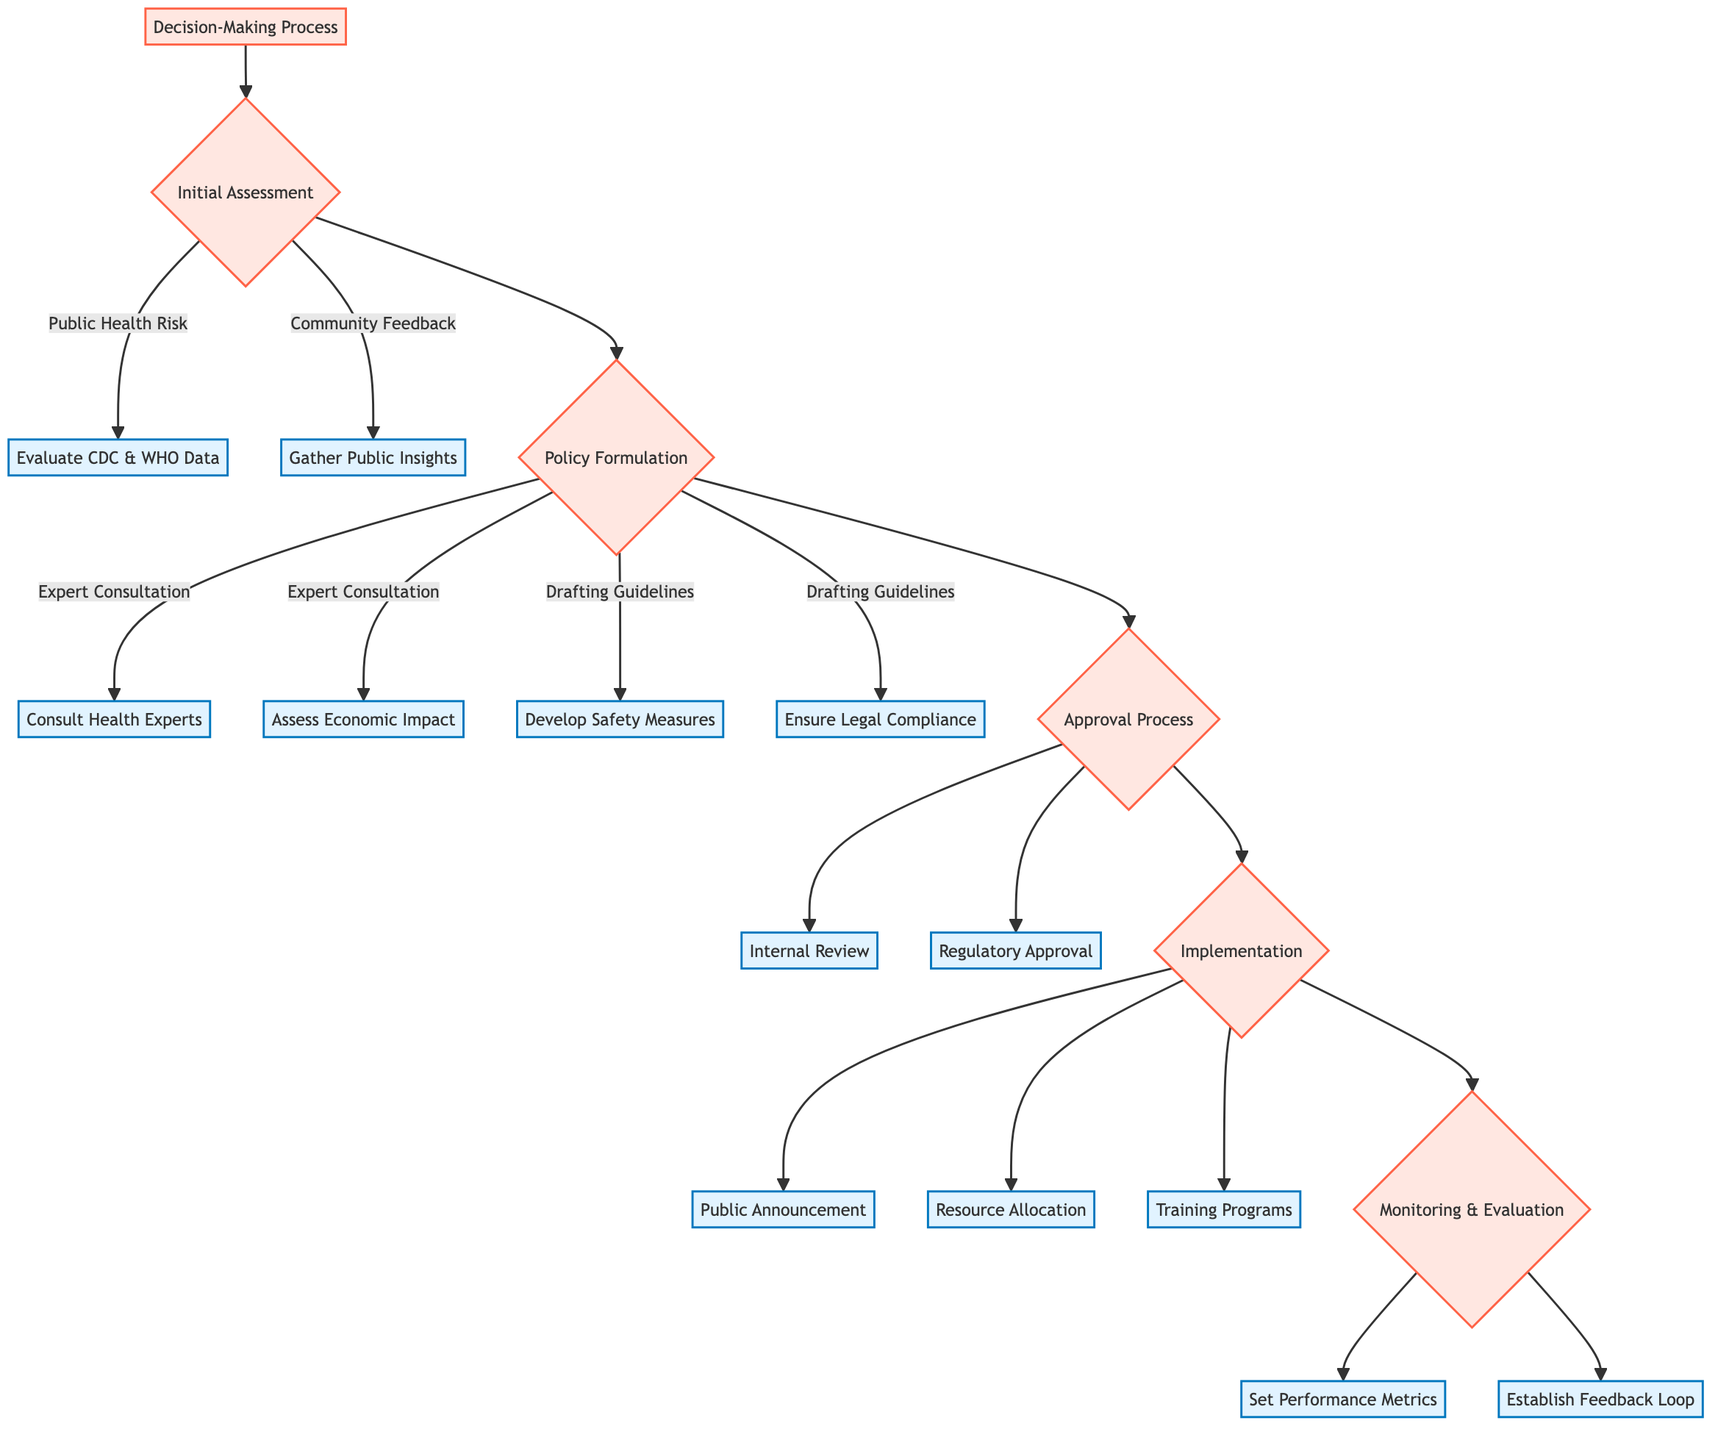What is the first step in the decision-making process? The diagram indicates that the first step in the decision-making process is "Initial Assessment."
Answer: Initial Assessment How many nodes are in the Approval Process section? The Approval Process section contains two nodes: "Internal Review" and "Regulatory Approval," totaling two nodes.
Answer: 2 Which sector is consulted for the economic impact during Policy Formulation? The diagram specifies that "Economic Advisors" are consulted to assess the economic impact during the Policy Formulation phase.
Answer: Economic Advisors What are the two main components of the Implementation phase? The Implementation phase consists of three components: "Public Announcement," "Resource Allocation," and "Training Programs." However, the question specifically asks for two main components, which could be taken from the list depending on interpretation. I'll list the first two: "Public Announcement" and "Resource Allocation".
Answer: Public Announcement, Resource Allocation Which step follows the Initial Assessment? According to the diagram, after the Initial Assessment, the next step is Policy Formulation.
Answer: Policy Formulation What is checked during the Monitoring and Evaluation phase? The key activities during the Monitoring and Evaluation phase involve setting up "Performance Metrics" and establishing a "Feedback Loop."
Answer: Performance Metrics, Feedback Loop How many types of consultations are there in the Policy Formulation process? The Policy Formulation process includes two types of consultations: one with "Public Health Experts" and another with "Economic Advisors."
Answer: 2 What is the purpose of the Internal Review? The diagram indicates that the purpose of the Internal Review is to conduct a review with senior political strategists and the captain as part of the Approval Process.
Answer: Conduct a review What measures are included in Drafting Guidelines? The Drafting Guidelines include two specific health safety measures: "Health Safety Measures" and "Legal Compliance."
Answer: Health Safety Measures, Legal Compliance What step comes directly after Regulatory Approval? Following Regulatory Approval, the next step in the process is Implementation.
Answer: Implementation 